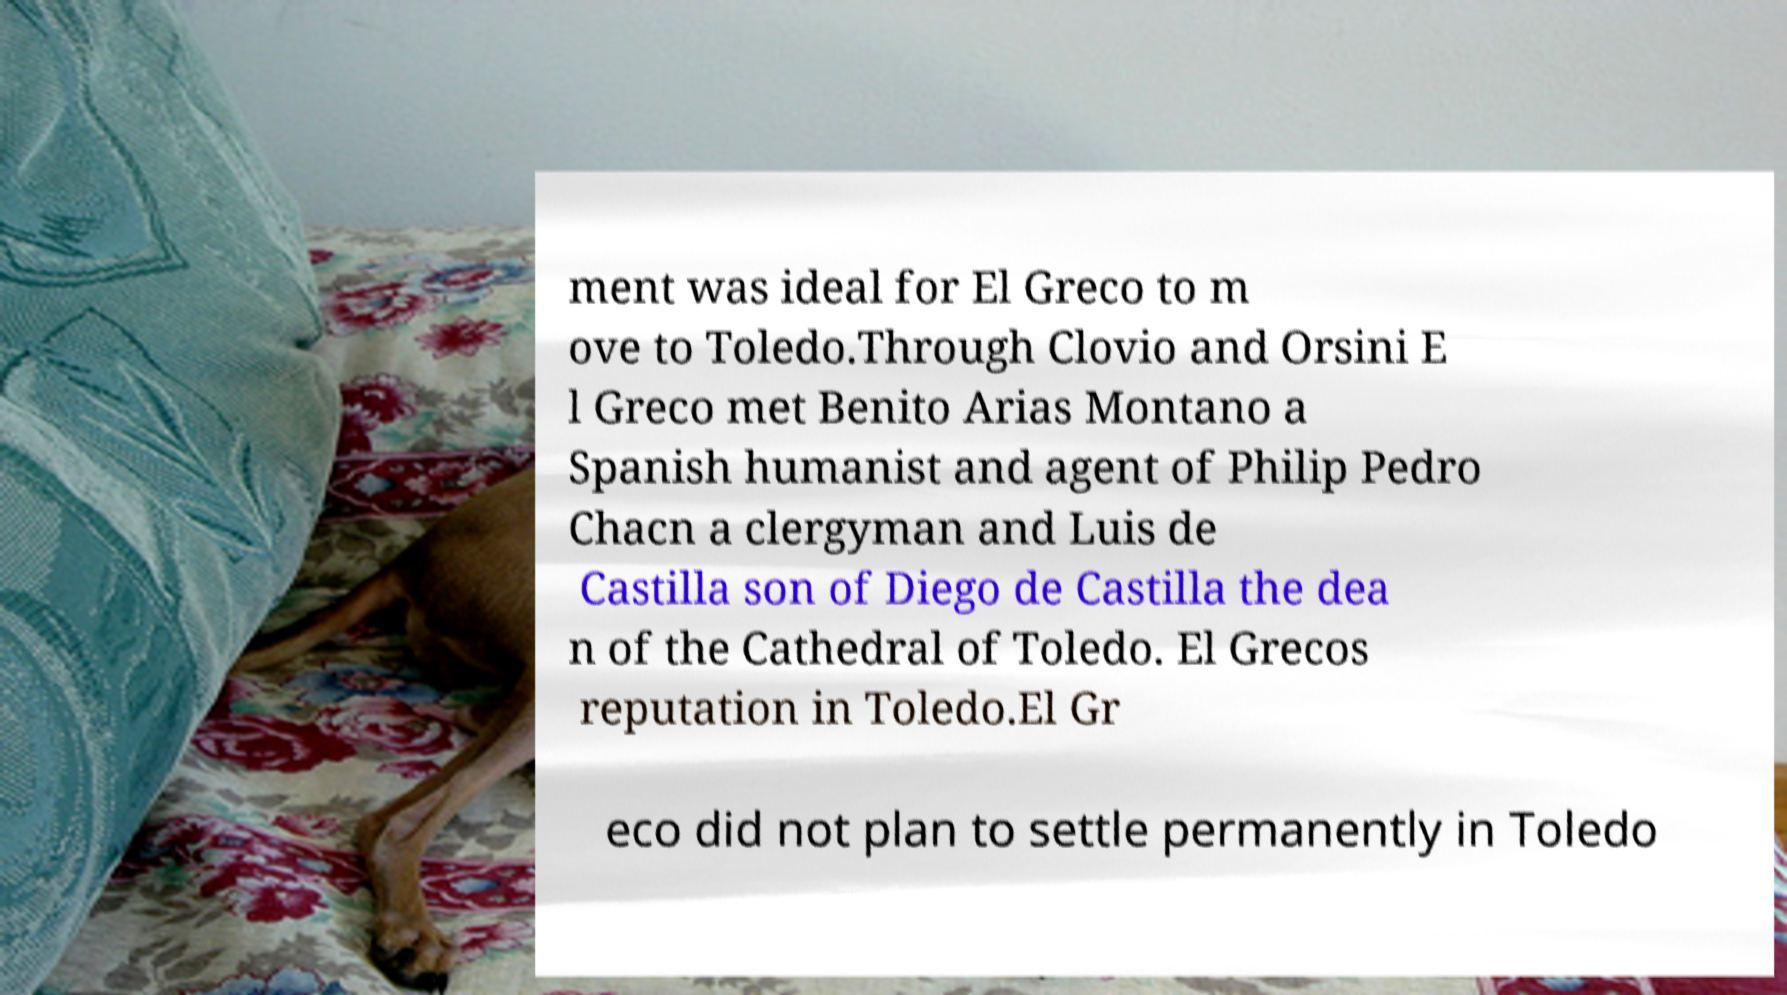Please identify and transcribe the text found in this image. ment was ideal for El Greco to m ove to Toledo.Through Clovio and Orsini E l Greco met Benito Arias Montano a Spanish humanist and agent of Philip Pedro Chacn a clergyman and Luis de Castilla son of Diego de Castilla the dea n of the Cathedral of Toledo. El Grecos reputation in Toledo.El Gr eco did not plan to settle permanently in Toledo 